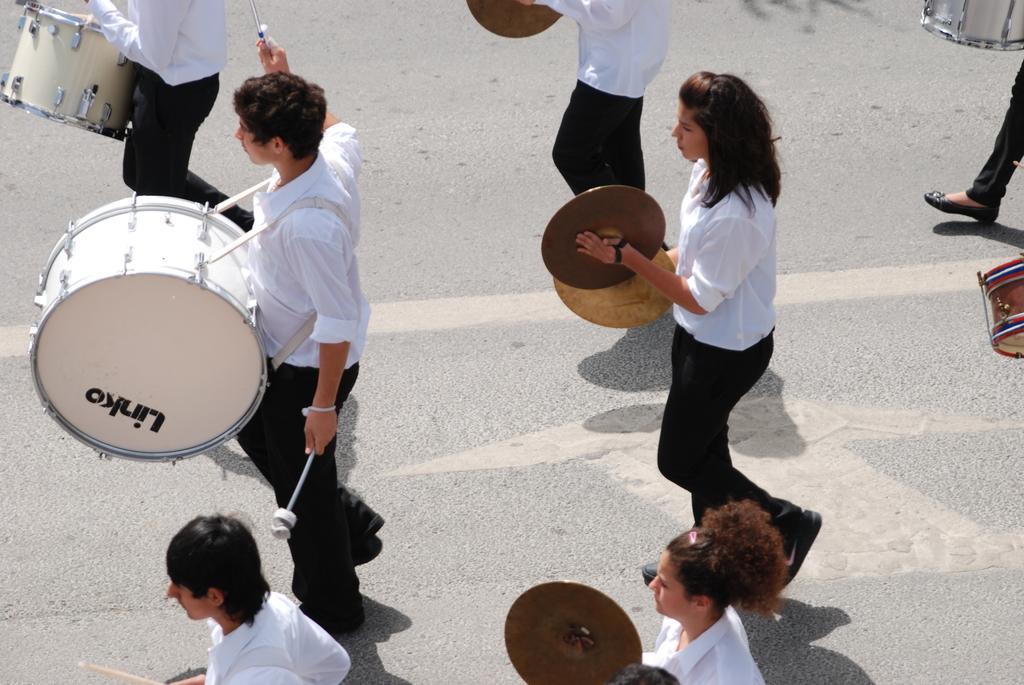Please provide a concise description of this image. In this image there are people playing musical instruments on the road. 